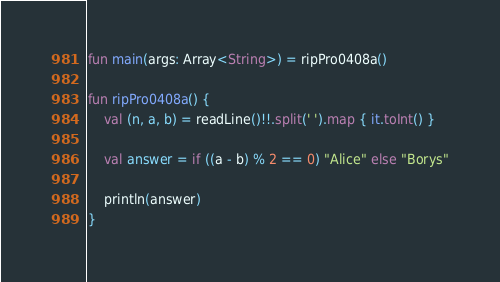<code> <loc_0><loc_0><loc_500><loc_500><_Kotlin_>fun main(args: Array<String>) = ripPro0408a()

fun ripPro0408a() {
    val (n, a, b) = readLine()!!.split(' ').map { it.toInt() }

    val answer = if ((a - b) % 2 == 0) "Alice" else "Borys"

    println(answer)
}
</code> 